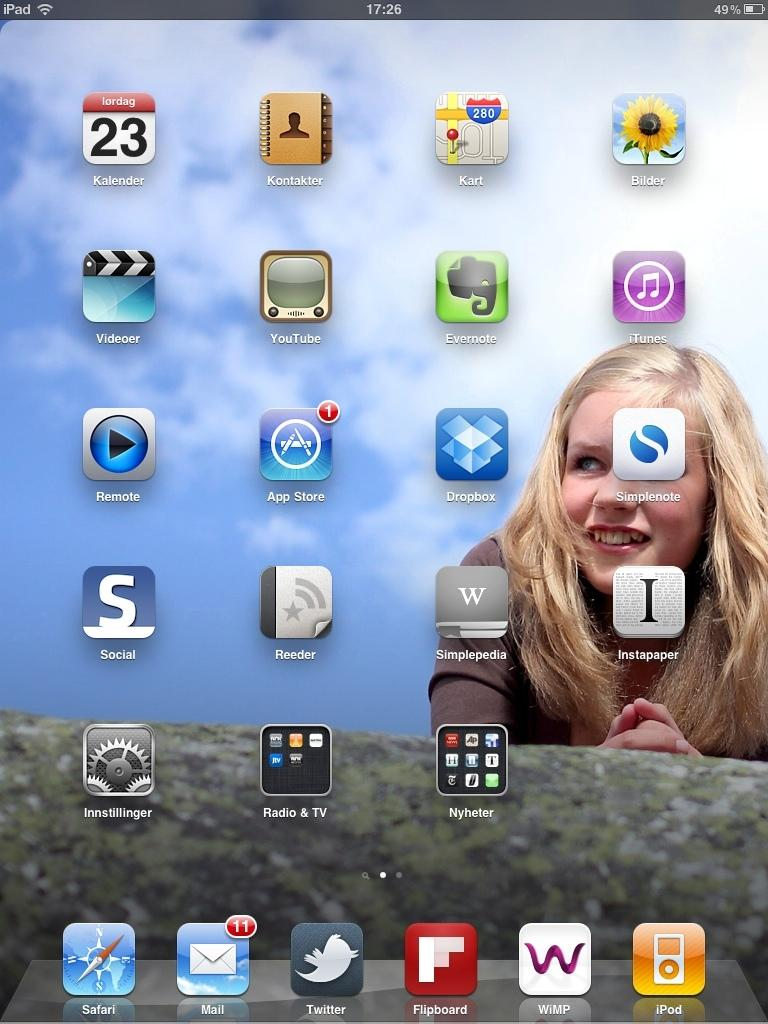What is the main subject in the foreground of the image? There is a phone screen in the foreground of the image. What can be seen on the phone screen? The phone screen displays a few apps. What is visible in the background of the phone screen? There is a woman's wallpaper in the background of the phone screen. Can you see any ants crawling on the phone screen in the image? No, there are no ants visible on the phone screen in the image. Is there a rainstorm happening in the background of the image? No, there is no rainstorm visible in the image; the background of the phone screen features a woman's wallpaper. 